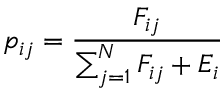Convert formula to latex. <formula><loc_0><loc_0><loc_500><loc_500>p _ { i j } = \frac { F _ { i j } } { \sum _ { j = 1 } ^ { N } F _ { i j } + E _ { i } }</formula> 